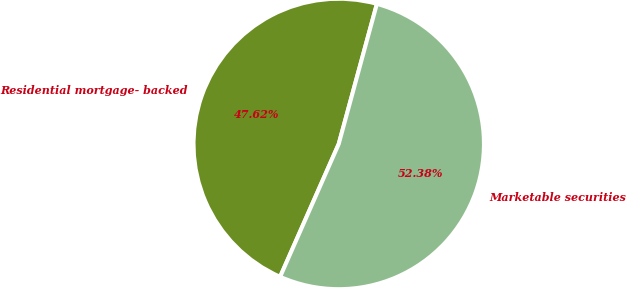Convert chart to OTSL. <chart><loc_0><loc_0><loc_500><loc_500><pie_chart><fcel>Residential mortgage- backed<fcel>Marketable securities<nl><fcel>47.62%<fcel>52.38%<nl></chart> 